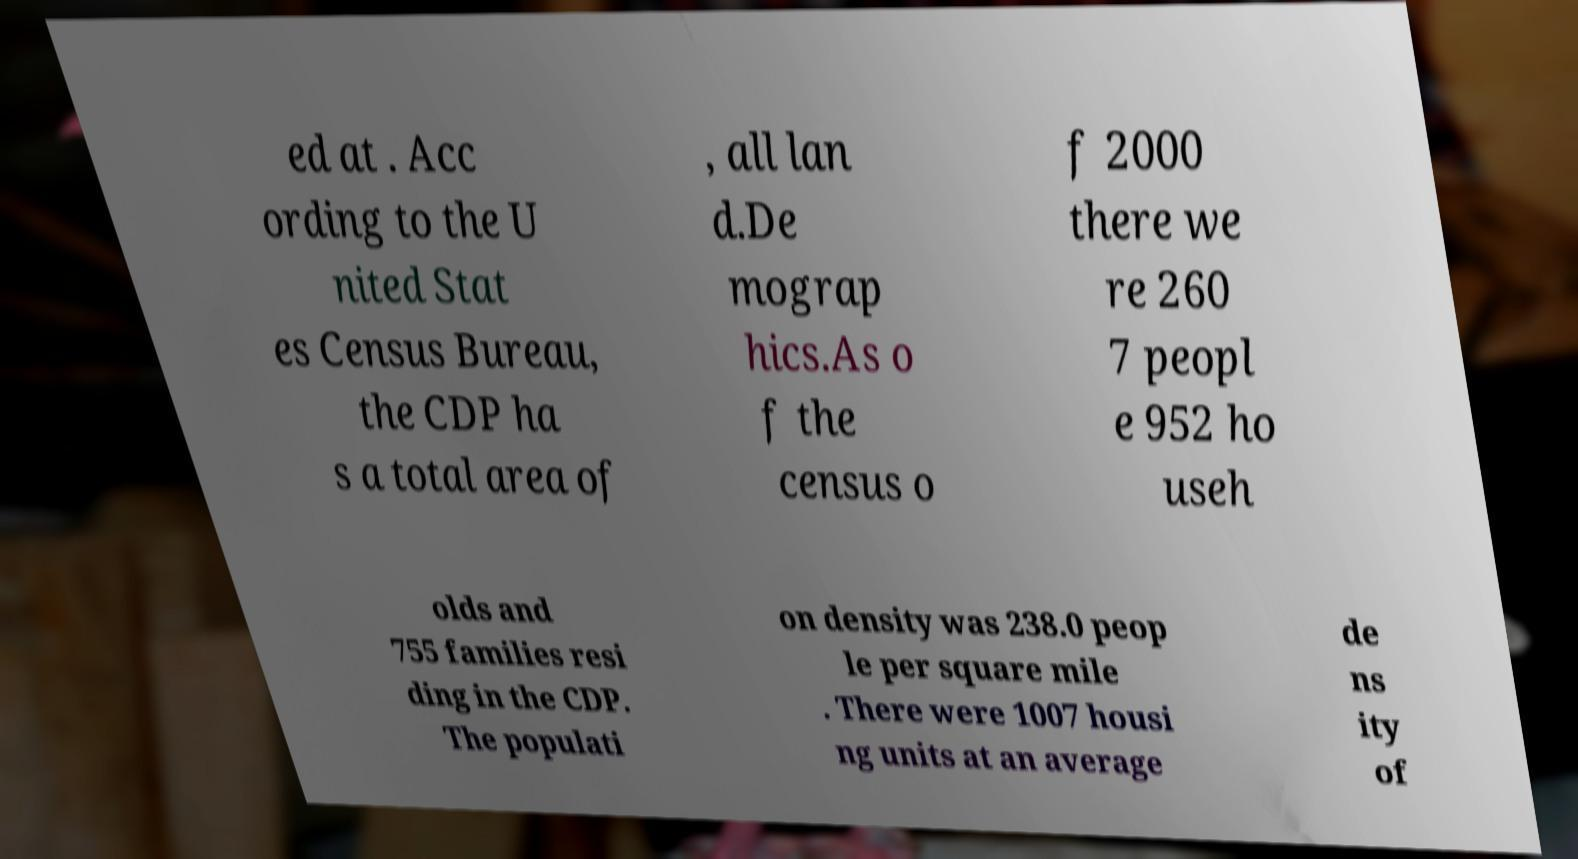I need the written content from this picture converted into text. Can you do that? ed at . Acc ording to the U nited Stat es Census Bureau, the CDP ha s a total area of , all lan d.De mograp hics.As o f the census o f 2000 there we re 260 7 peopl e 952 ho useh olds and 755 families resi ding in the CDP. The populati on density was 238.0 peop le per square mile . There were 1007 housi ng units at an average de ns ity of 